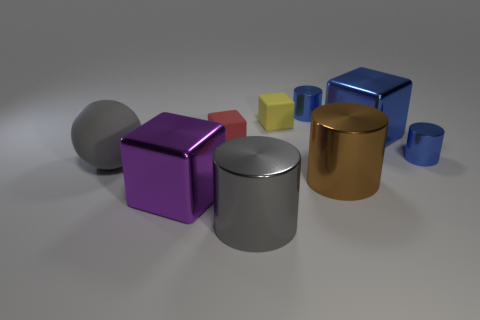What number of other rubber things have the same color as the big matte object?
Keep it short and to the point. 0. Are there any other things that have the same shape as the large rubber object?
Give a very brief answer. No. Are there any large blue metallic things that are behind the purple block that is to the left of the gray object to the right of the large gray sphere?
Your response must be concise. Yes. How many big cylinders have the same material as the blue cube?
Ensure brevity in your answer.  2. Does the gray object that is in front of the large purple metal cube have the same size as the gray sphere that is to the left of the large blue block?
Give a very brief answer. Yes. There is a shiny cylinder in front of the metal cube in front of the large gray matte object that is in front of the red rubber object; what color is it?
Provide a succinct answer. Gray. Is there a yellow object of the same shape as the gray shiny object?
Ensure brevity in your answer.  No. Is the number of yellow blocks that are in front of the gray sphere the same as the number of large purple cubes that are behind the red matte cube?
Make the answer very short. Yes. There is a small matte thing that is left of the tiny yellow rubber cube; does it have the same shape as the brown shiny thing?
Offer a very short reply. No. Do the red matte thing and the yellow object have the same shape?
Offer a very short reply. Yes. 